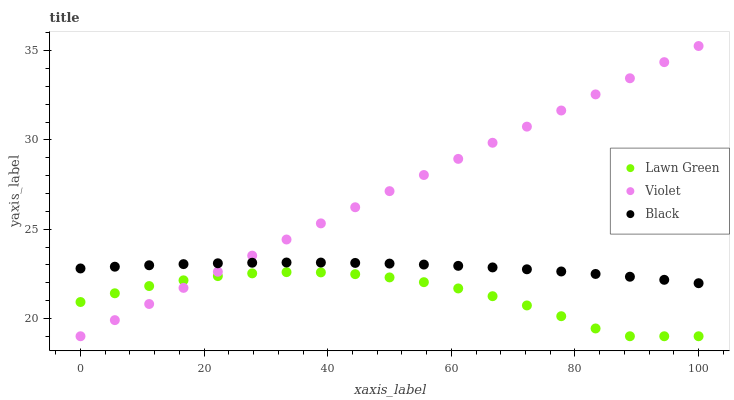Does Lawn Green have the minimum area under the curve?
Answer yes or no. Yes. Does Violet have the maximum area under the curve?
Answer yes or no. Yes. Does Black have the minimum area under the curve?
Answer yes or no. No. Does Black have the maximum area under the curve?
Answer yes or no. No. Is Violet the smoothest?
Answer yes or no. Yes. Is Lawn Green the roughest?
Answer yes or no. Yes. Is Black the smoothest?
Answer yes or no. No. Is Black the roughest?
Answer yes or no. No. Does Lawn Green have the lowest value?
Answer yes or no. Yes. Does Black have the lowest value?
Answer yes or no. No. Does Violet have the highest value?
Answer yes or no. Yes. Does Black have the highest value?
Answer yes or no. No. Is Lawn Green less than Black?
Answer yes or no. Yes. Is Black greater than Lawn Green?
Answer yes or no. Yes. Does Violet intersect Black?
Answer yes or no. Yes. Is Violet less than Black?
Answer yes or no. No. Is Violet greater than Black?
Answer yes or no. No. Does Lawn Green intersect Black?
Answer yes or no. No. 